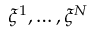Convert formula to latex. <formula><loc_0><loc_0><loc_500><loc_500>\xi ^ { 1 } , \dots , \xi ^ { N }</formula> 